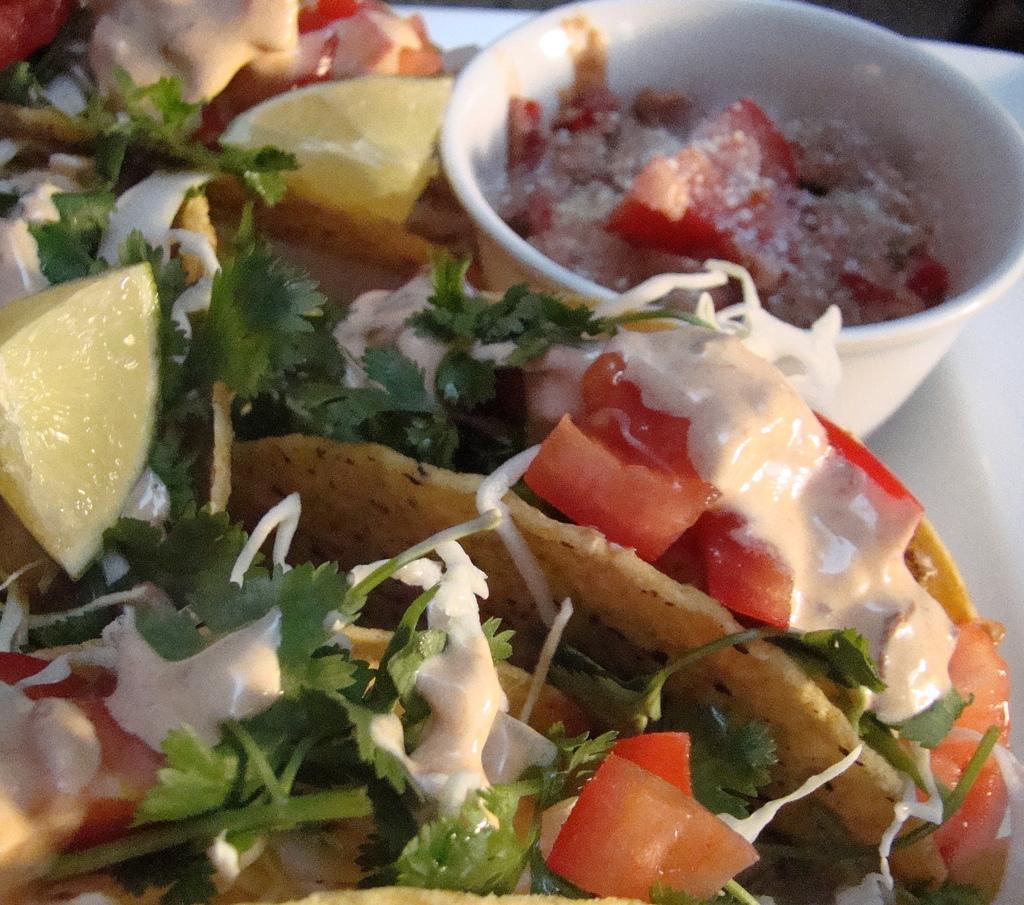Can you describe this image briefly? In this image there is one plate and in that place there are some food items, and one bowl and in that bowl there is some food. 